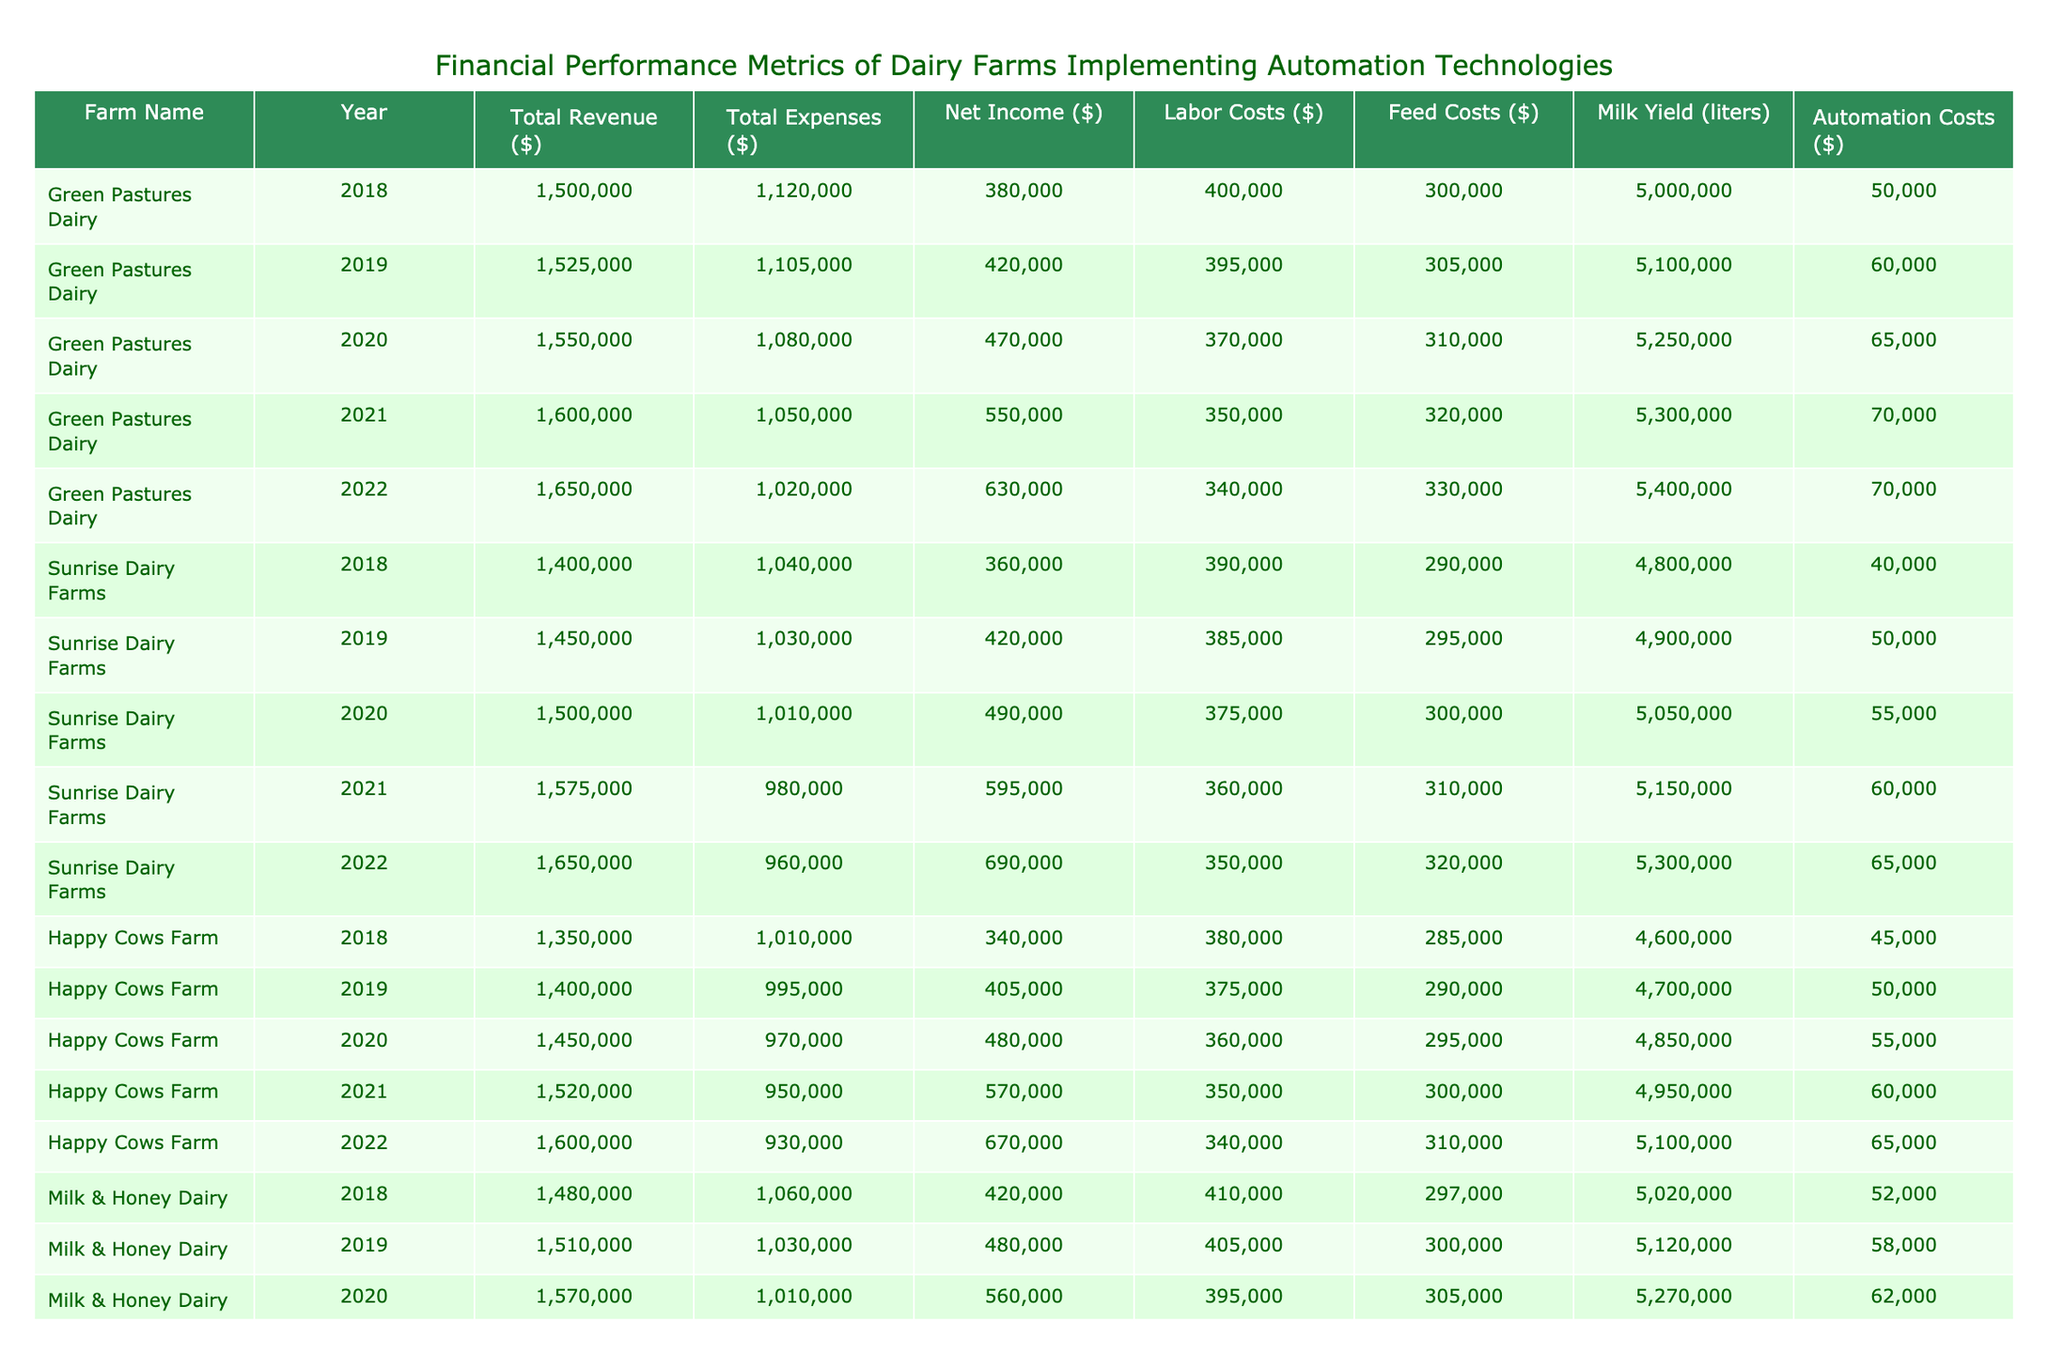What was the net income for Green Pastures Dairy in 2022? The net income for Green Pastures Dairy in 2022 is listed directly in the table as 630,000.
Answer: 630000 What were the total expenses for Sunrise Dairy Farms in 2021? The total expenses for Sunrise Dairy Farms in 2021 can be directly found in the table, which shows that the expenses were 980,000.
Answer: 980000 What is the average labor cost per year for Happy Cows Farm over the five years? To find the average labor cost for Happy Cows Farm, I sum the labor costs for each year: (380000 + 375000 + 360000 + 350000 + 340000) = 1800000. Then divide by the number of years (5): 1800000 / 5 = 360000.
Answer: 360000 Did Milk & Honey Dairy experience an increase in total revenue every year from 2018 to 2022? By examining the total revenue column for Milk & Honey Dairy, we see that the revenue increased each year from 2018 (1,480,000) to 2022 (1,700,000), confirming an increase.
Answer: Yes What was the total net income for all farms in 2020? To calculate the total net income for all farms in 2020, add the net incomes: Green Pastures (470,000) + Sunrise (490,000) + Happy Cows (480,000) + Milk & Honey (560,000) = 2,000,000.
Answer: 2000000 What is the difference in total revenue between the highest and lowest performing farm in 2019? First, from the table, the highest total revenue in 2019 is 1,525,000 from Green Pastures Dairy, while the lowest is 1,450,000 from Sunrise Dairy Farms. The difference is calculated as 1,525,000 - 1,450,000 = 75,000.
Answer: 75000 What was the feed cost for the farm with the highest total revenue in 2021? In 2021, the highest total revenue is from Green Pastures Dairy, which has a feed cost of 320,000 according to the table.
Answer: 320000 How much did Automation Costs increase from 2018 to 2022 for Happy Cows Farm? The automation costs are listed as 45,000 for 2018 and 65,000 for 2022. The increase can be calculated as 65,000 - 45,000 = 20,000.
Answer: 20000 Was the net income for Sunrise Dairy Farms higher in 2020 or 2021? From the table, the net income for Sunrise Dairy Farms in 2020 is 490,000, while in 2021 it is 595,000. Since 595,000 is greater than 490,000, 2021 had a higher net income.
Answer: Yes 